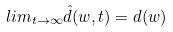<formula> <loc_0><loc_0><loc_500><loc_500>l i m _ { t \rightarrow \infty } \hat { d } ( w , t ) = d ( w )</formula> 